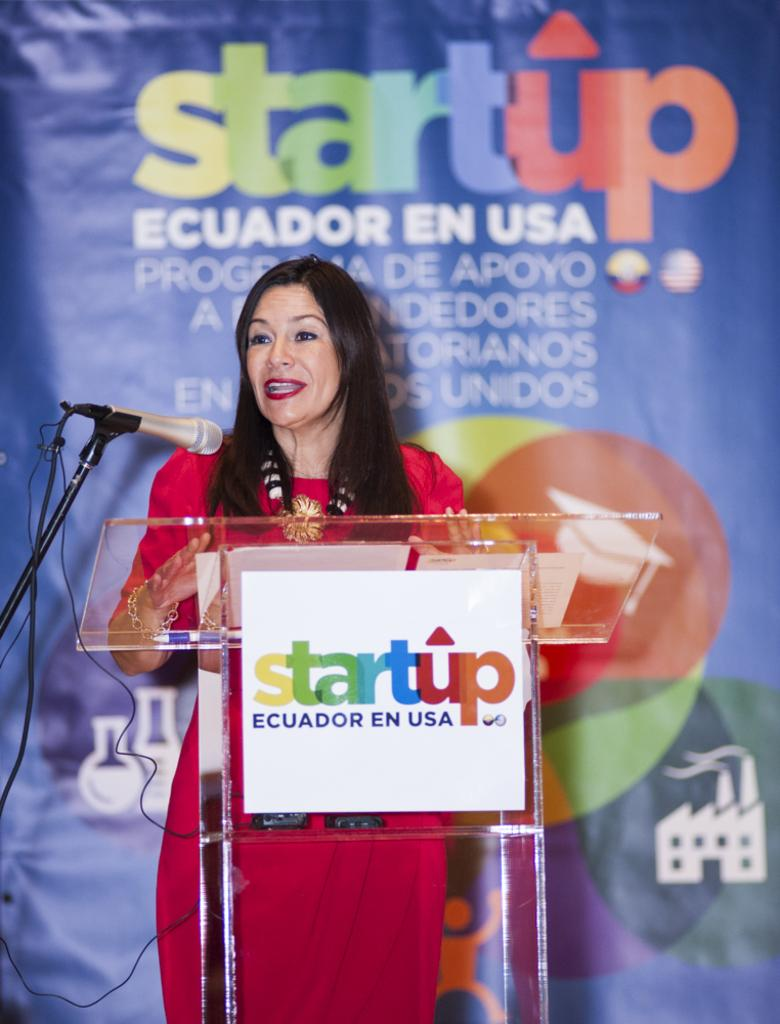What is the person in the image doing? The person is standing in the image. What is the person wearing? The person is wearing a red dress. What object is in front of the person? There is a podium in front of the person. What is on the podium? There is a microphone on the podium. What can be seen in the background of the image? The background of the image includes a blue banner. What advice is the person's grandfather giving in the image? There is no mention of a grandfather or any advice being given in the image. 